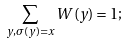<formula> <loc_0><loc_0><loc_500><loc_500>\sum _ { y , \sigma ( y ) = x } W ( y ) = 1 ;</formula> 